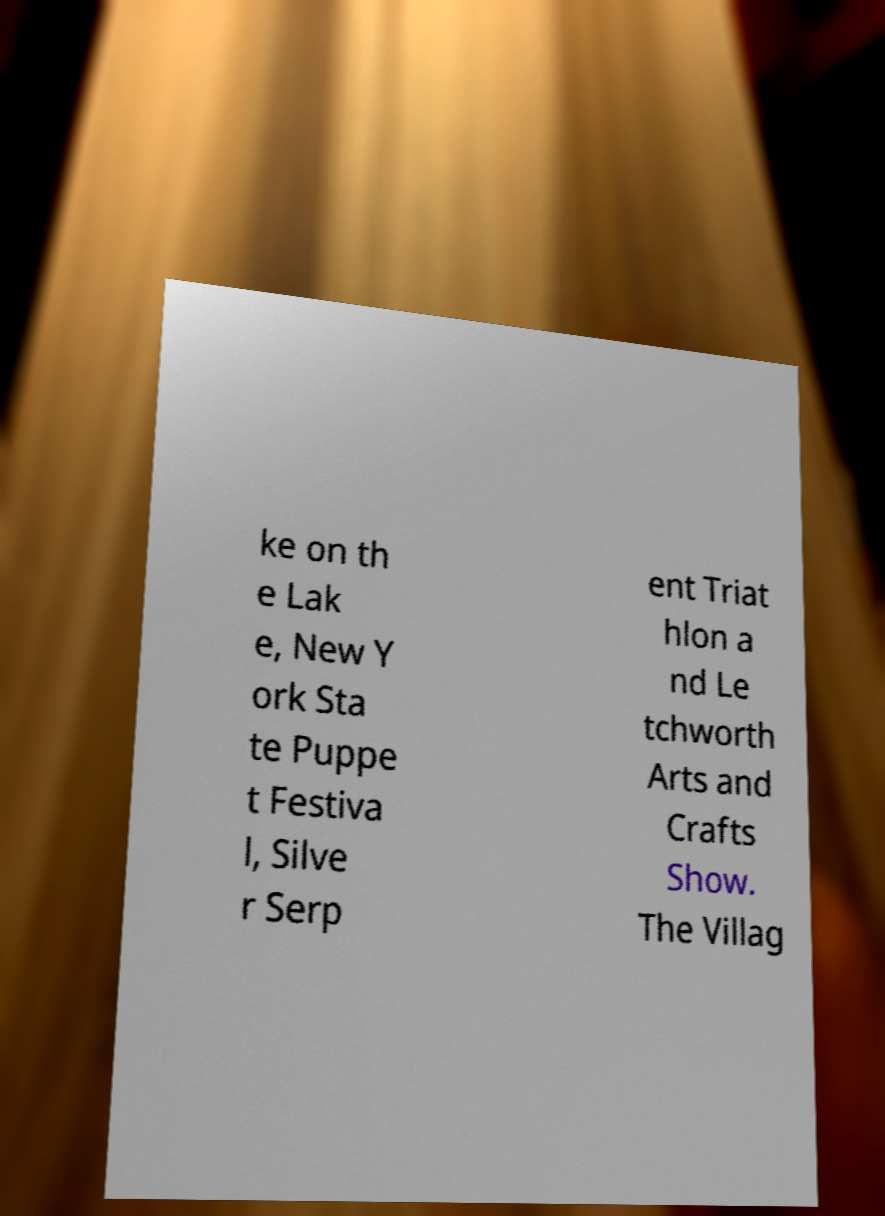Please read and relay the text visible in this image. What does it say? ke on th e Lak e, New Y ork Sta te Puppe t Festiva l, Silve r Serp ent Triat hlon a nd Le tchworth Arts and Crafts Show. The Villag 